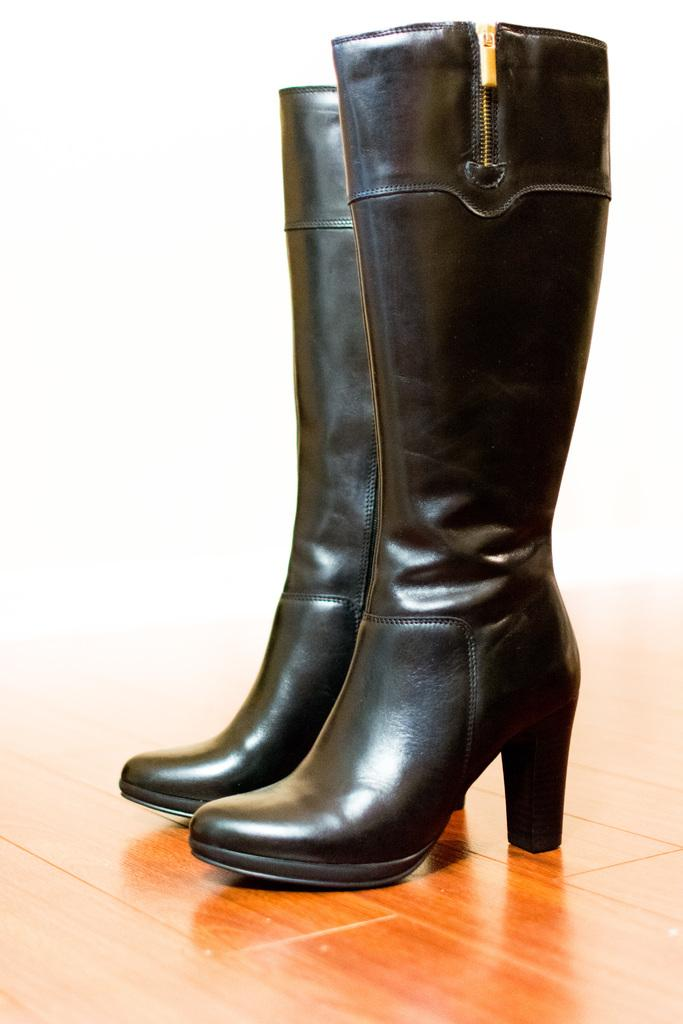What type of footwear is visible in the image? There are black color boots in the image. What is the color of the surface on which the boots are placed? The boots are on a brown color surface. What color is the background of the image? The background of the image is white. How many cakes are stacked on top of each other in the image? There are no cakes present in the image. What type of coil is used to create the boots in the image? The image does not show the construction of the boots, so it is not possible to determine the type of coil used. 